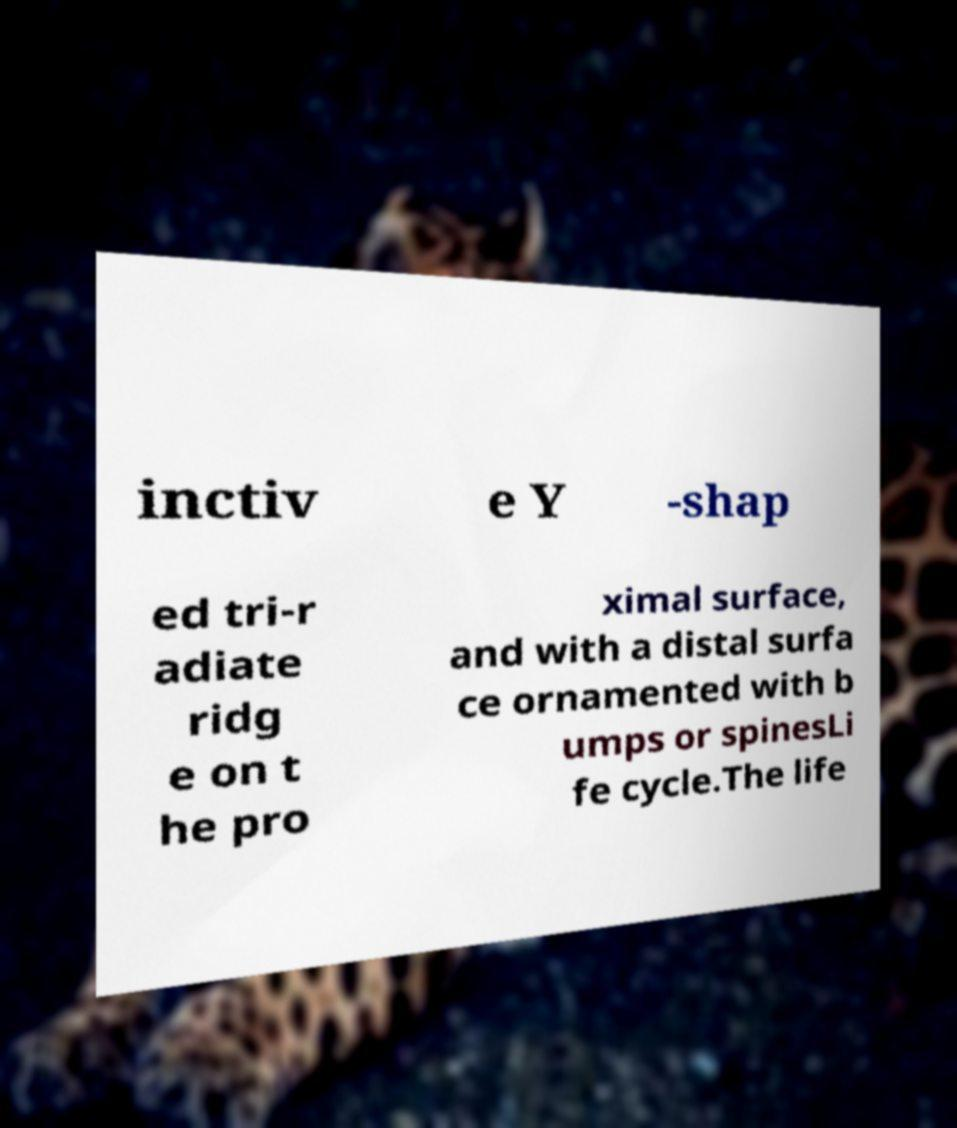For documentation purposes, I need the text within this image transcribed. Could you provide that? inctiv e Y -shap ed tri-r adiate ridg e on t he pro ximal surface, and with a distal surfa ce ornamented with b umps or spinesLi fe cycle.The life 